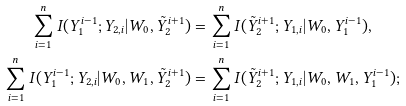<formula> <loc_0><loc_0><loc_500><loc_500>\sum _ { i = 1 } ^ { n } I ( Y _ { 1 } ^ { i - 1 } ; Y _ { 2 , i } | W _ { 0 } , \tilde { Y } _ { 2 } ^ { i + 1 } ) & = \sum _ { i = 1 } ^ { n } I ( \tilde { Y } _ { 2 } ^ { i + 1 } ; Y _ { 1 , i } | W _ { 0 } , Y _ { 1 } ^ { i - 1 } ) , \\ \sum _ { i = 1 } ^ { n } I ( Y _ { 1 } ^ { i - 1 } ; Y _ { 2 , i } | W _ { 0 } , W _ { 1 } , \tilde { Y } _ { 2 } ^ { i + 1 } ) & = \sum _ { i = 1 } ^ { n } I ( \tilde { Y } _ { 2 } ^ { i + 1 } ; Y _ { 1 , i } | W _ { 0 } , W _ { 1 } , Y _ { 1 } ^ { i - 1 } ) ;</formula> 